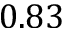Convert formula to latex. <formula><loc_0><loc_0><loc_500><loc_500>0 . 8 3</formula> 